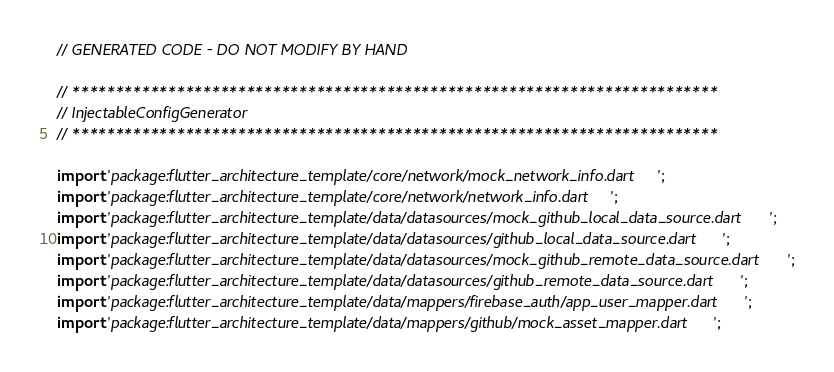<code> <loc_0><loc_0><loc_500><loc_500><_Dart_>// GENERATED CODE - DO NOT MODIFY BY HAND

// **************************************************************************
// InjectableConfigGenerator
// **************************************************************************

import 'package:flutter_architecture_template/core/network/mock_network_info.dart';
import 'package:flutter_architecture_template/core/network/network_info.dart';
import 'package:flutter_architecture_template/data/datasources/mock_github_local_data_source.dart';
import 'package:flutter_architecture_template/data/datasources/github_local_data_source.dart';
import 'package:flutter_architecture_template/data/datasources/mock_github_remote_data_source.dart';
import 'package:flutter_architecture_template/data/datasources/github_remote_data_source.dart';
import 'package:flutter_architecture_template/data/mappers/firebase_auth/app_user_mapper.dart';
import 'package:flutter_architecture_template/data/mappers/github/mock_asset_mapper.dart';</code> 